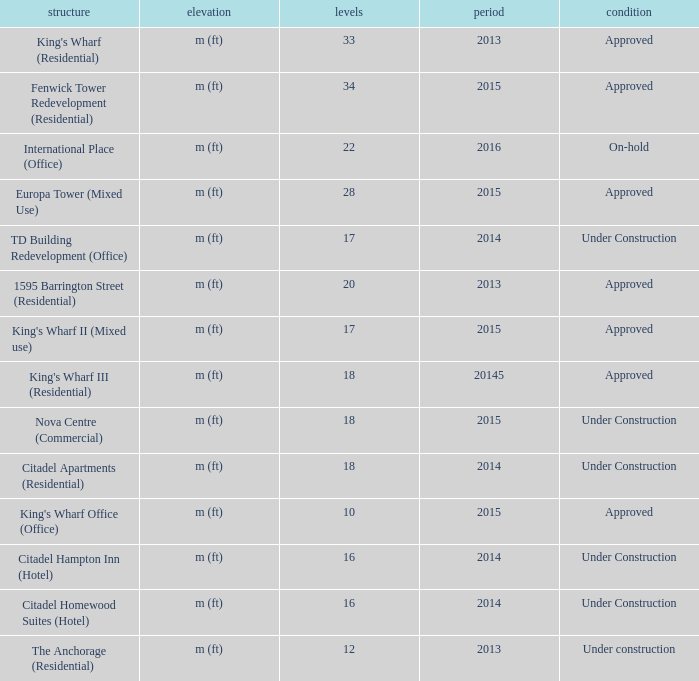What edifice exhibits 2013 and contains more than 20 stories? King's Wharf (Residential). 